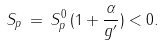<formula> <loc_0><loc_0><loc_500><loc_500>S _ { p } \, = \, S _ { p } ^ { 0 } \, ( 1 + \frac { \alpha } { g ^ { \prime } } ) < 0 .</formula> 